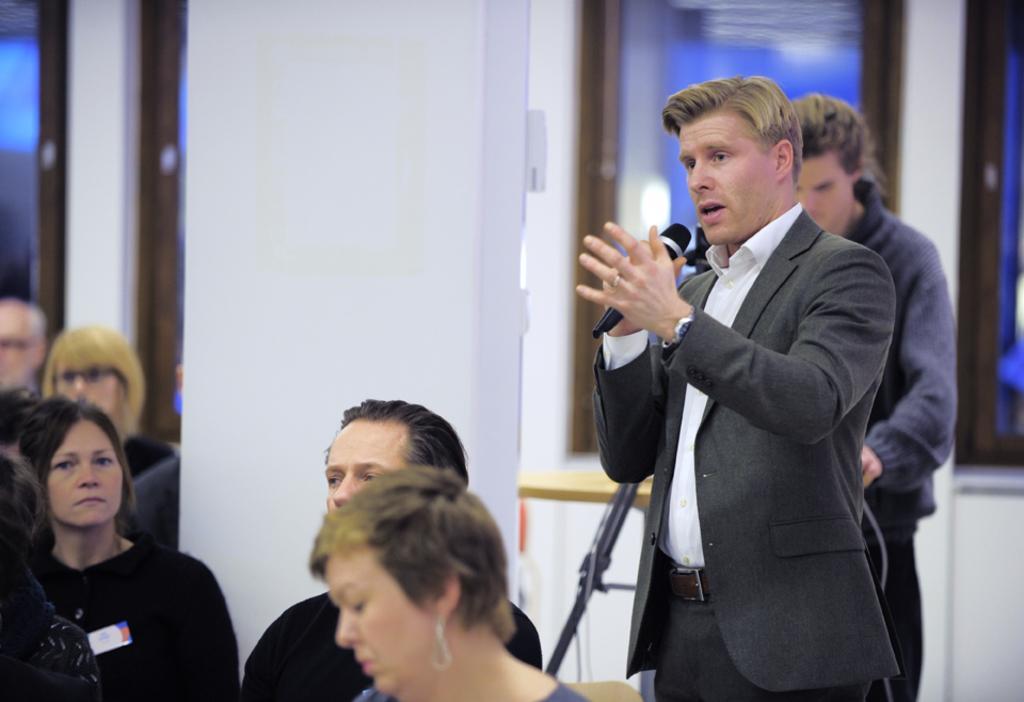Describe this image in one or two sentences. In this picture there is a person wearing black suit is holding a mic and in front of him there are some other people sitting and behind there is an other man. 